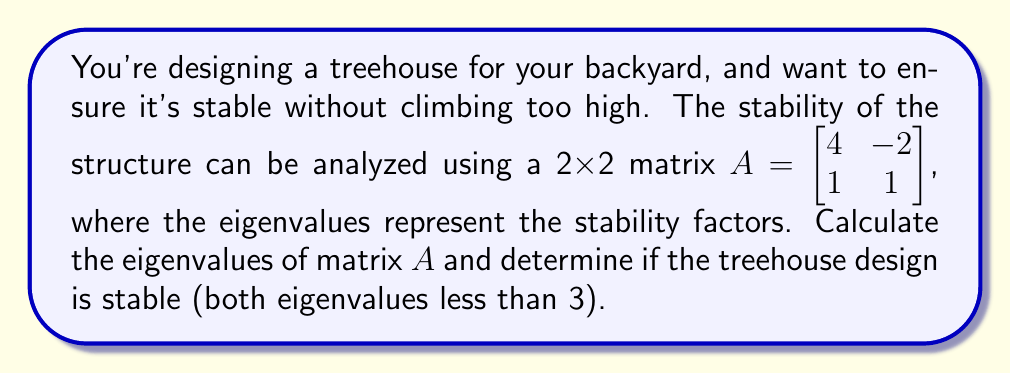Can you solve this math problem? To find the eigenvalues of matrix $A$, we need to solve the characteristic equation:

1) First, we set up the equation: $det(A - \lambda I) = 0$

2) Expand the determinant:
   $$det\begin{pmatrix}
   4-\lambda & -2 \\
   1 & 1-\lambda
   \end{pmatrix} = 0$$

3) Calculate the determinant:
   $(4-\lambda)(1-\lambda) - (-2)(1) = 0$

4) Simplify:
   $4 - 4\lambda + \lambda^2 - \lambda + 2 = 0$
   $\lambda^2 - 5\lambda + 6 = 0$

5) Solve the quadratic equation using the quadratic formula:
   $\lambda = \frac{5 \pm \sqrt{25 - 24}}{2} = \frac{5 \pm 1}{2}$

6) The eigenvalues are:
   $\lambda_1 = 3$ and $\lambda_2 = 2$

7) Check if both eigenvalues are less than 3:
   $\lambda_1 = 3$ is not less than 3
   $\lambda_2 = 2$ is less than 3

Since one eigenvalue is not less than 3, the treehouse design is not considered stable according to the given criteria.
Answer: Eigenvalues: $\lambda_1 = 3$, $\lambda_2 = 2$. Treehouse design is not stable. 